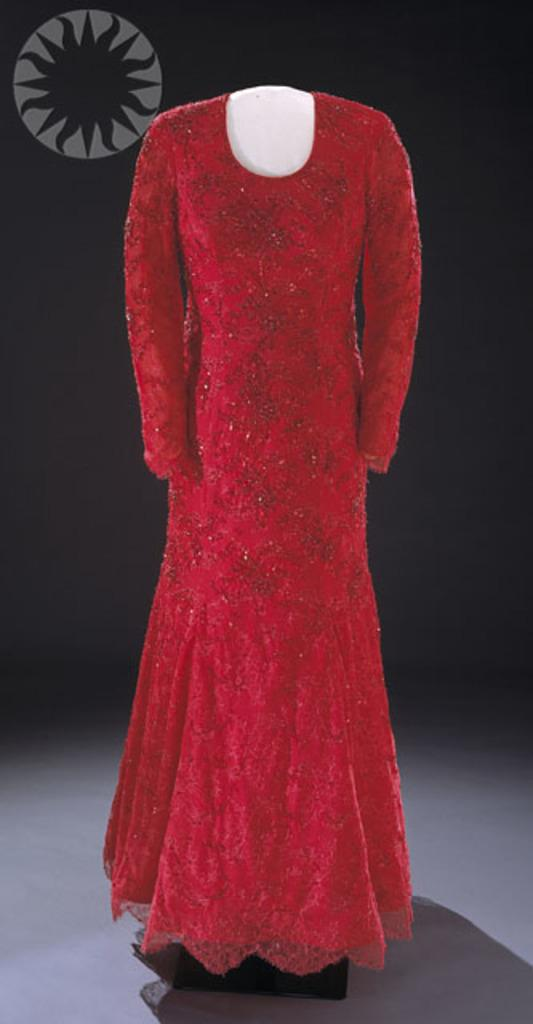What is the main subject of the image? There is a mannequin in the image. What is the mannequin wearing? The mannequin is wearing a red frock. Where is the mannequin located in the image? The mannequin is placed on the floor. What is the color of the background in the image? The background of the image is black. What type of berry is the mannequin holding in the image? There is no berry present in the image, and the mannequin is not holding anything. 